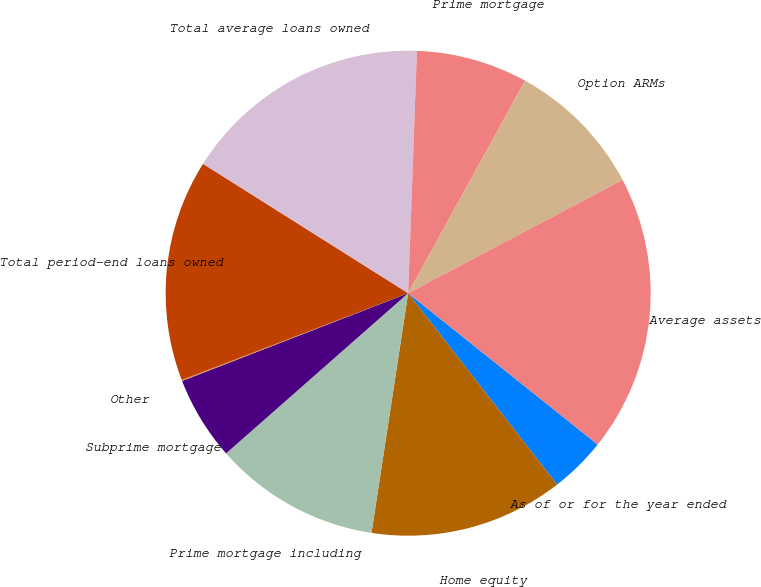Convert chart. <chart><loc_0><loc_0><loc_500><loc_500><pie_chart><fcel>As of or for the year ended<fcel>Home equity<fcel>Prime mortgage including<fcel>Subprime mortgage<fcel>Other<fcel>Total period-end loans owned<fcel>Total average loans owned<fcel>Prime mortgage<fcel>Option ARMs<fcel>Average assets<nl><fcel>3.75%<fcel>12.94%<fcel>11.1%<fcel>5.59%<fcel>0.07%<fcel>14.78%<fcel>16.62%<fcel>7.43%<fcel>9.26%<fcel>18.46%<nl></chart> 